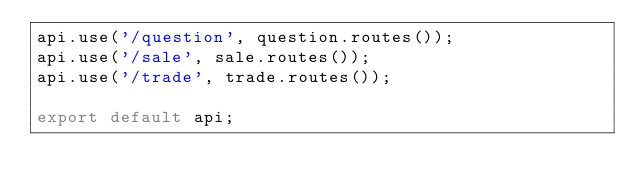Convert code to text. <code><loc_0><loc_0><loc_500><loc_500><_JavaScript_>api.use('/question', question.routes());
api.use('/sale', sale.routes());
api.use('/trade', trade.routes());

export default api;</code> 